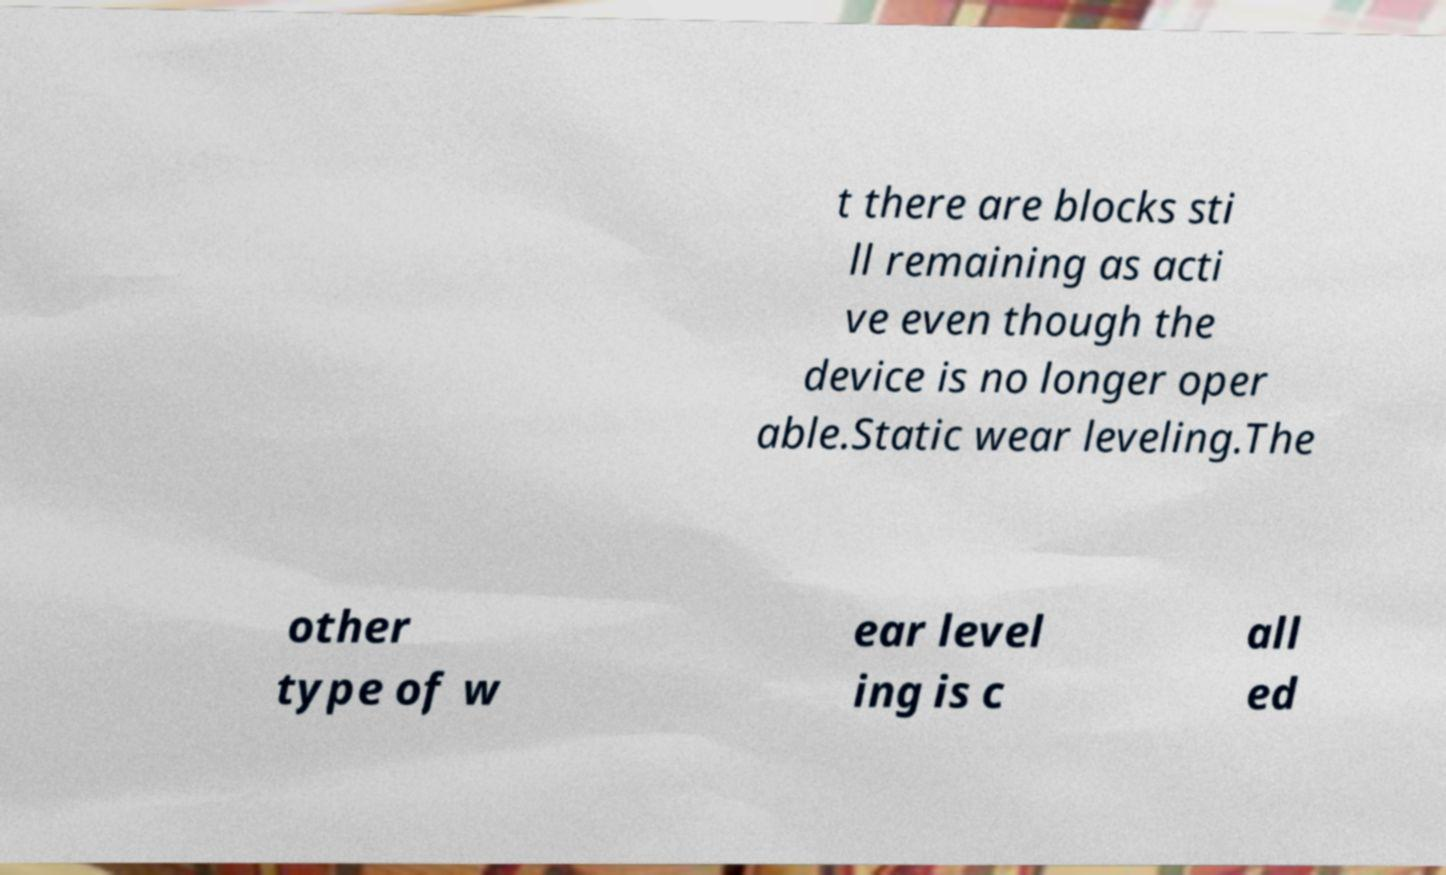Can you accurately transcribe the text from the provided image for me? t there are blocks sti ll remaining as acti ve even though the device is no longer oper able.Static wear leveling.The other type of w ear level ing is c all ed 